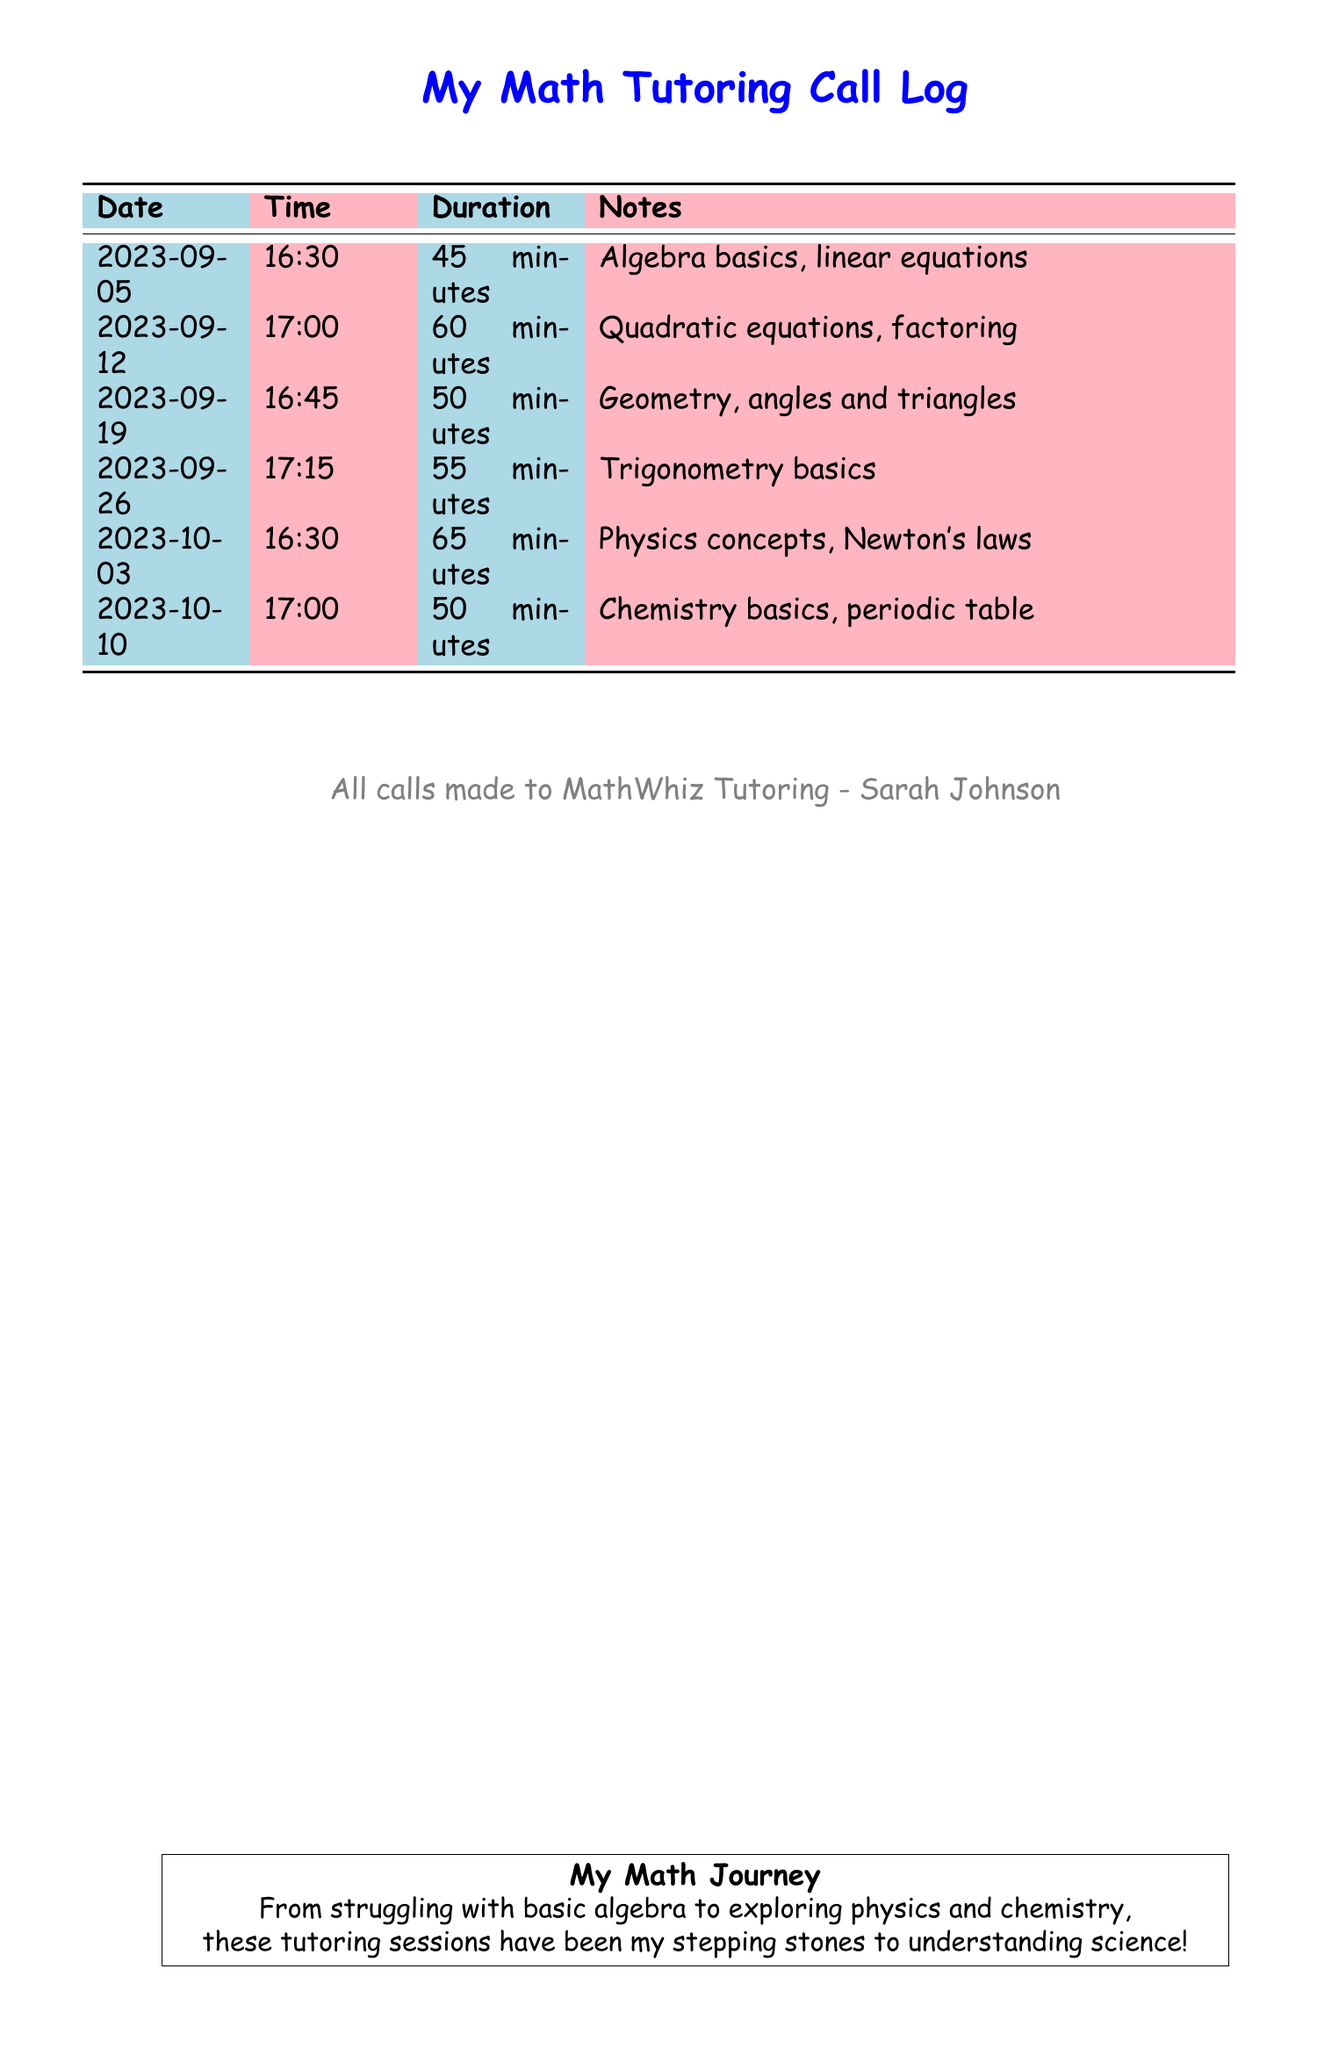What is the date of the first call? The first call's date is listed as the earliest date in the log.
Answer: 2023-09-05 How long was the call on October 3rd? The duration of the call on October 3rd is specified in the log.
Answer: 65 minutes Which topic was discussed on September 12th? The topic for that date is explicitly mentioned in the notes section for the call.
Answer: Quadratic equations, factoring How many calls were made in total? The total number of calls is the count of rows in the log.
Answer: 6 What time was the last call made? The time of the last call is shown in the log.
Answer: 17:00 Which subject was discussed most recently? The last entry in the log indicates the subject matter of the most recent call.
Answer: Chemistry basics, periodic table What is the name of the math tutor? The tutor's name is provided in the footer of the document.
Answer: Sarah Johnson Which call lasted longest? The call with the longest duration is identified by comparing all listed durations.
Answer: October 3rd How many minutes was the first tutoring session? The duration for the first tutoring session can be found in the log.
Answer: 45 minutes 